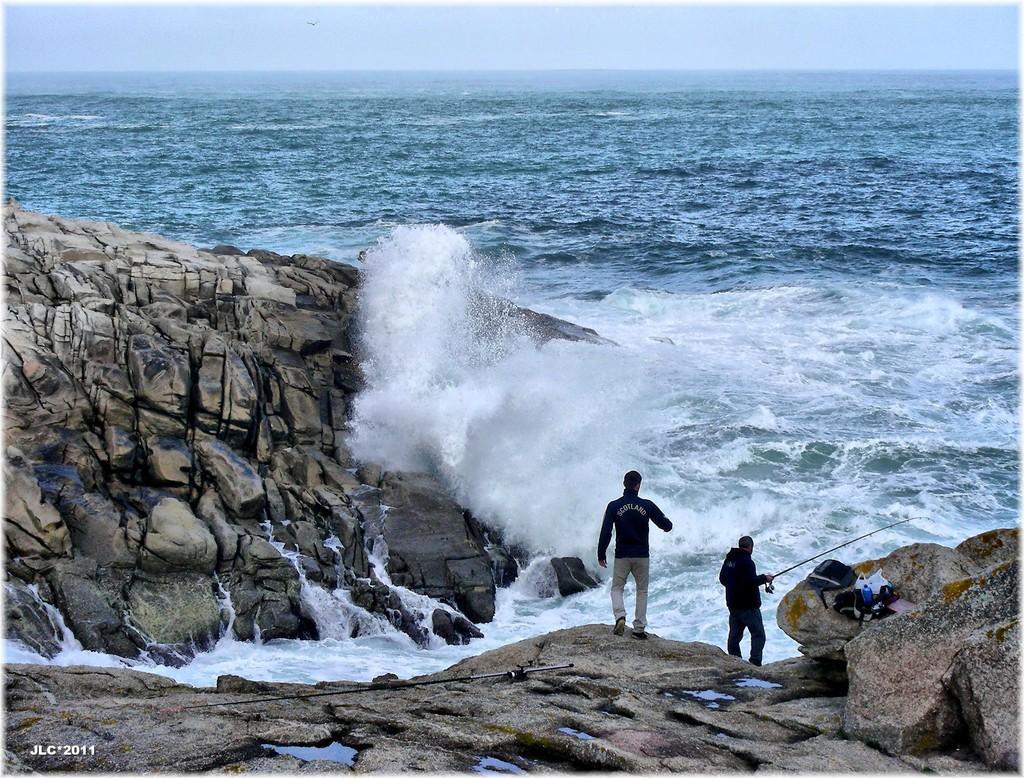Can you describe this image briefly? Here we can see two men and he is holding a stick with his hand. There are rocks, bags, and bottles. This is water. In the background there is sky. 